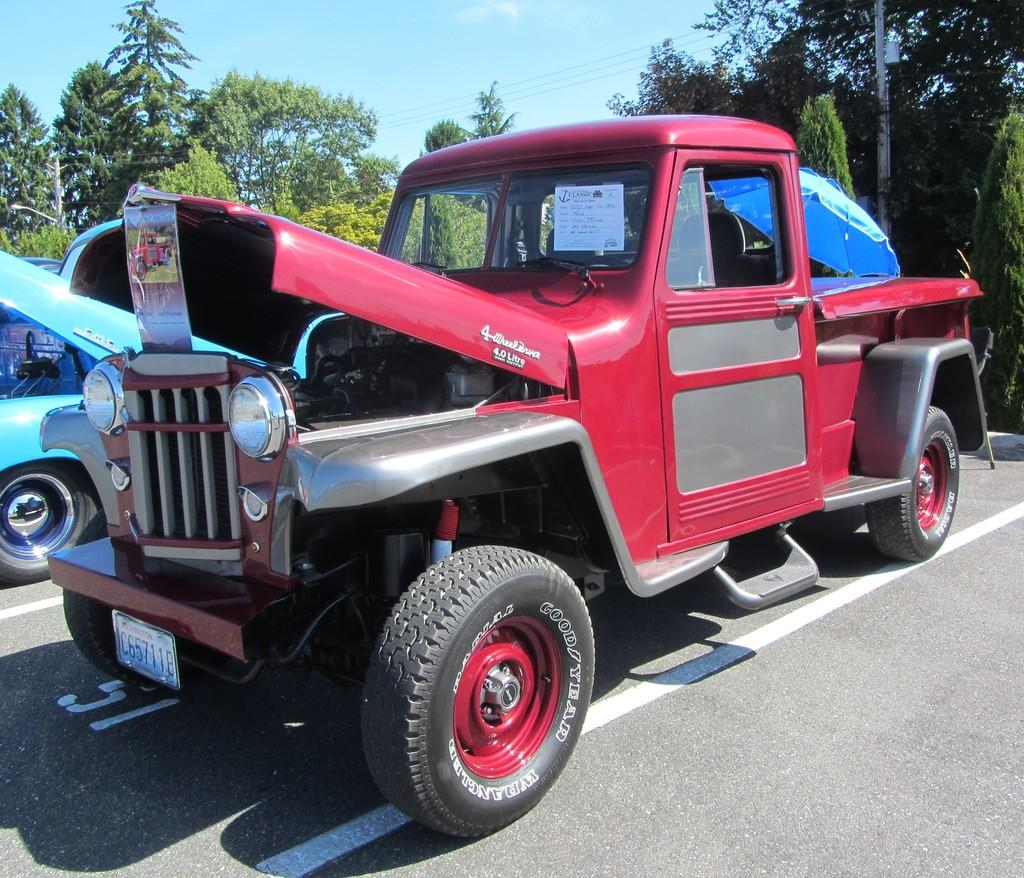What is the main subject of the image? The main subject of the image is a vehicle with a number plate. What is attached to the vehicle? There is a poster and an umbrella attached to the vehicle. What can be seen in the background of the image? There are trees and sky visible in the background of the image. How many vehicles are in the image? There are two vehicles in the image. What is the setting of the image? The image is set on a road. What type of berry is being used as a decoration on the vehicle? There is no berry present on the vehicle in the image. What color is the trick that the vehicle is performing? The image does not depict a trick being performed by the vehicle. 